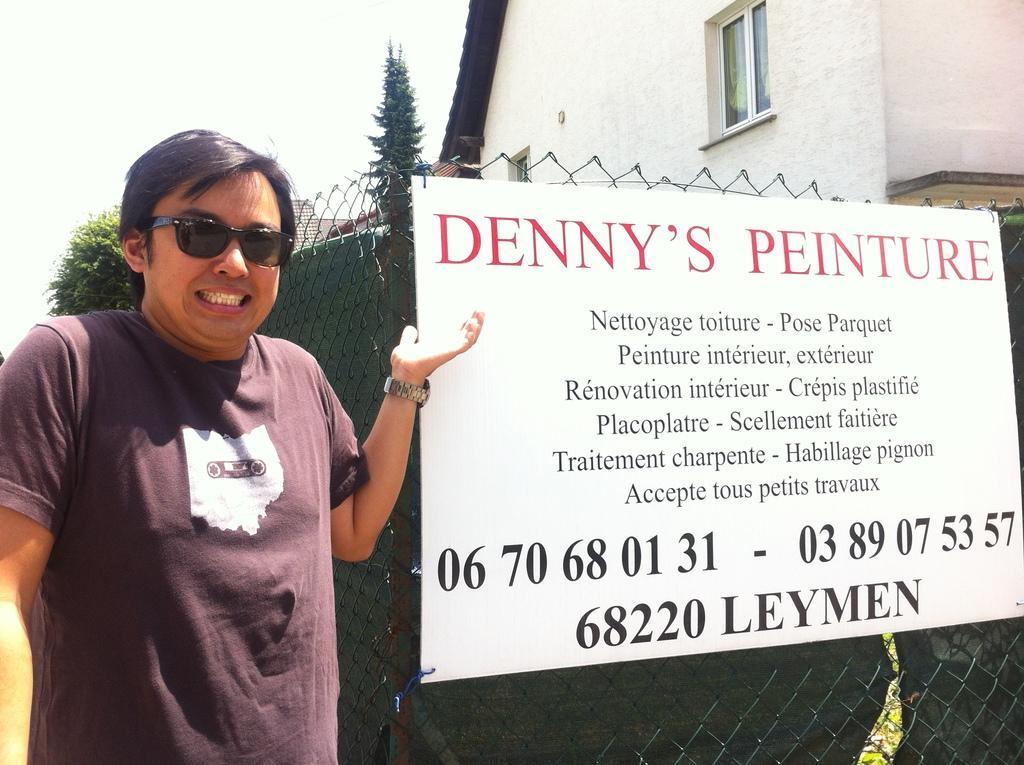In one or two sentences, can you explain what this image depicts? In this image we can see a person standing, advertising board attached to the mesh, building, trees and sky. 